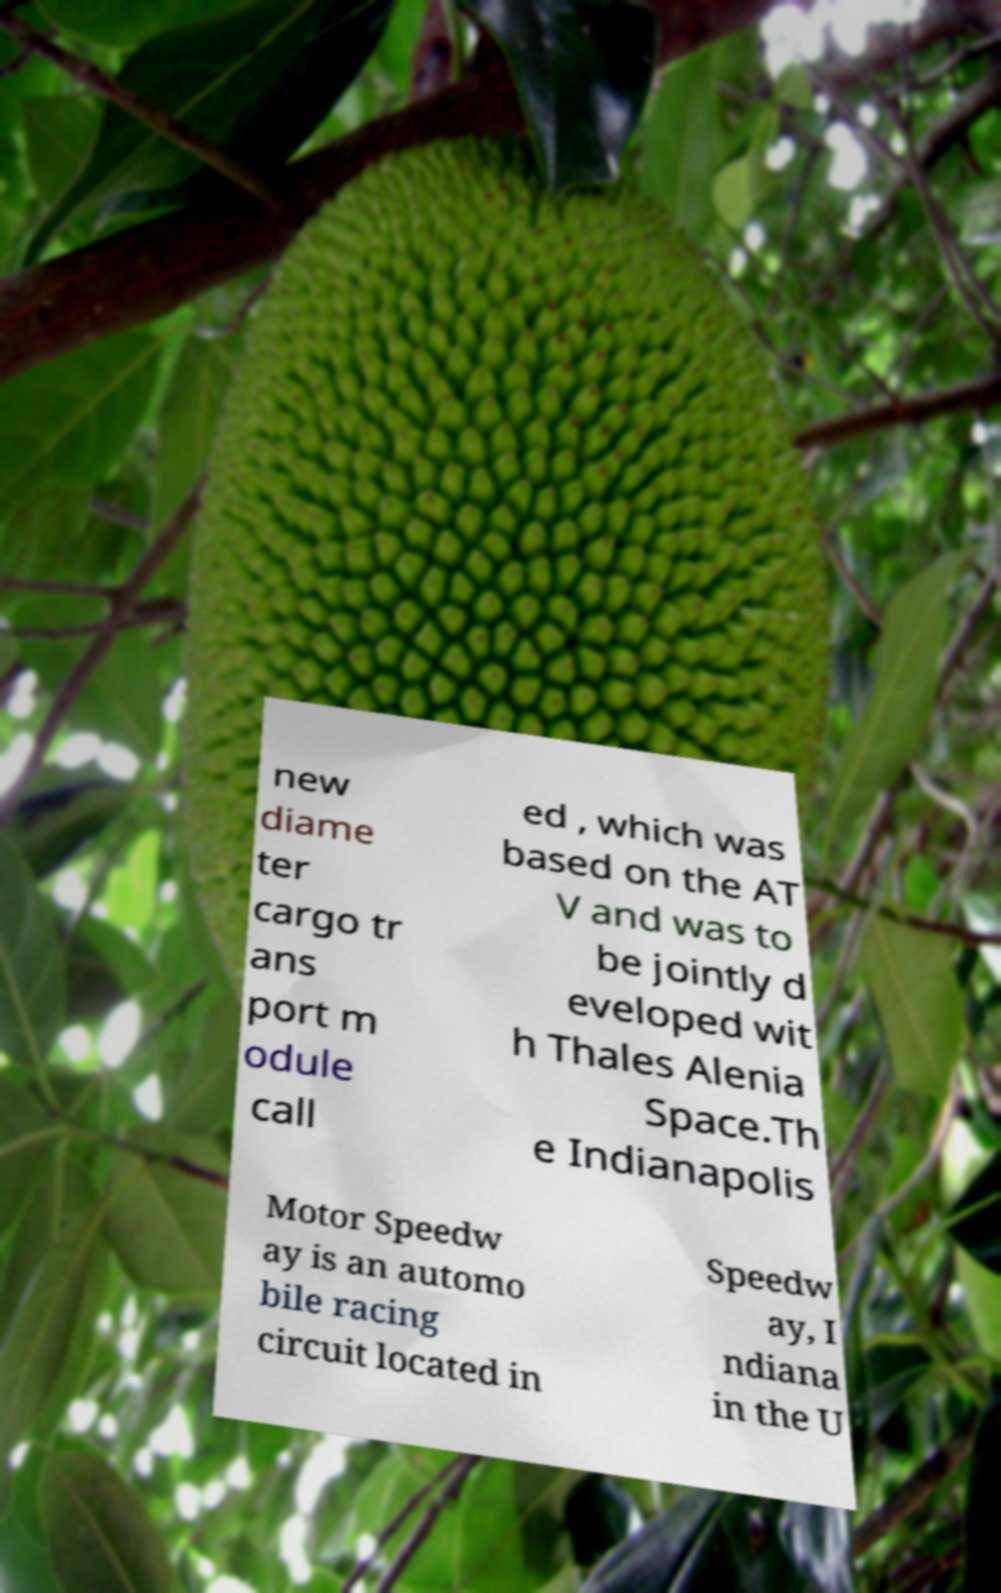Could you extract and type out the text from this image? new diame ter cargo tr ans port m odule call ed , which was based on the AT V and was to be jointly d eveloped wit h Thales Alenia Space.Th e Indianapolis Motor Speedw ay is an automo bile racing circuit located in Speedw ay, I ndiana in the U 